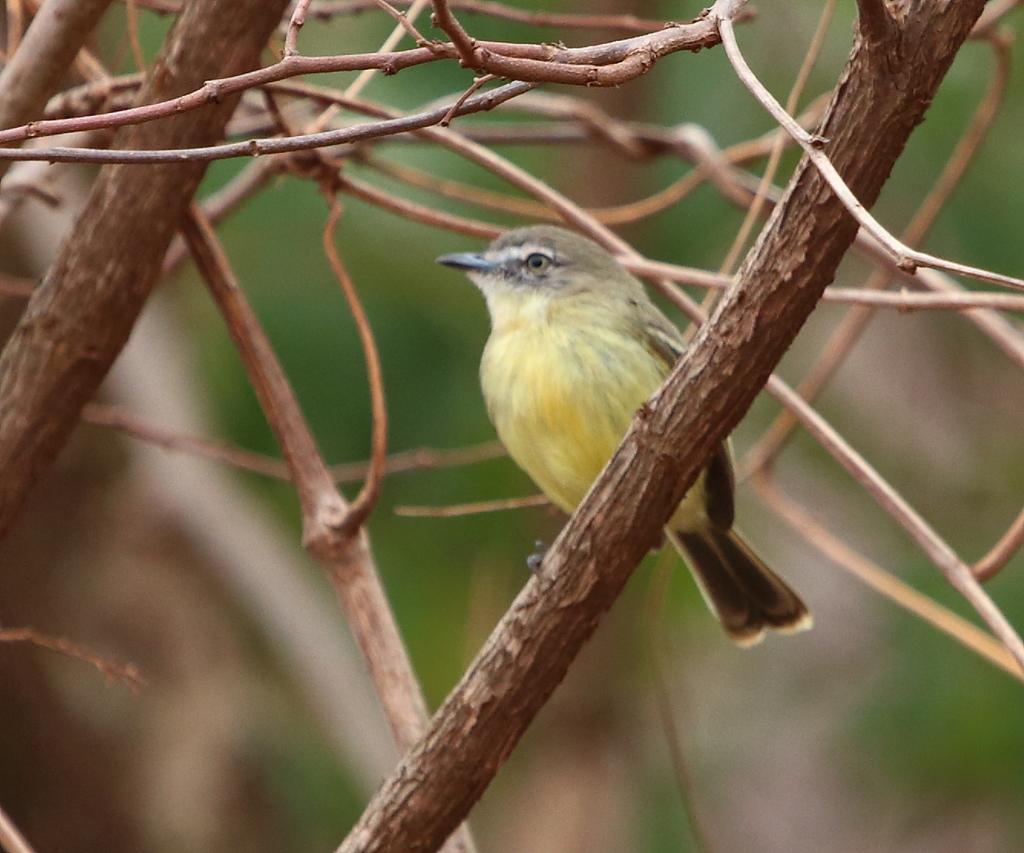Can you describe this image briefly? In this image there is a bird in the branches. 